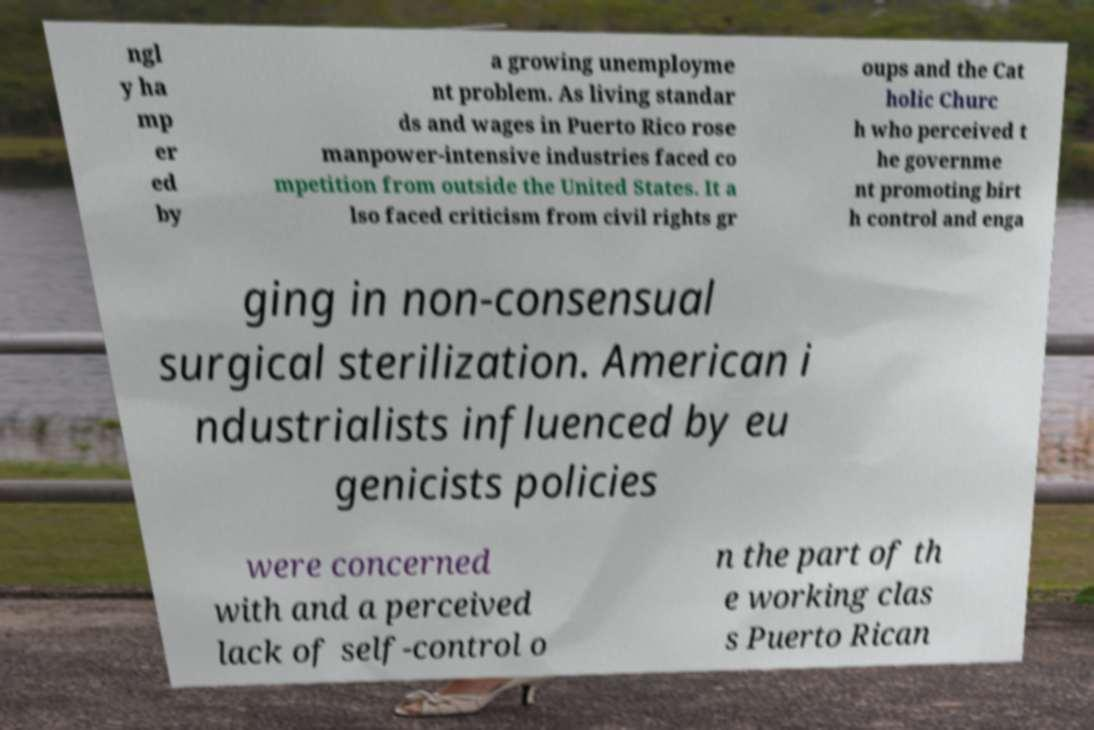I need the written content from this picture converted into text. Can you do that? ngl y ha mp er ed by a growing unemployme nt problem. As living standar ds and wages in Puerto Rico rose manpower-intensive industries faced co mpetition from outside the United States. It a lso faced criticism from civil rights gr oups and the Cat holic Churc h who perceived t he governme nt promoting birt h control and enga ging in non-consensual surgical sterilization. American i ndustrialists influenced by eu genicists policies were concerned with and a perceived lack of self-control o n the part of th e working clas s Puerto Rican 